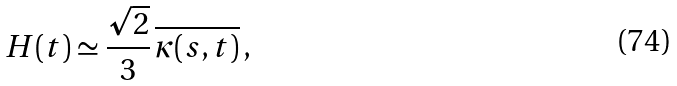<formula> <loc_0><loc_0><loc_500><loc_500>H ( t ) \simeq \frac { \sqrt { 2 } } { 3 } \, \overline { \kappa ( s , t ) } \, ,</formula> 